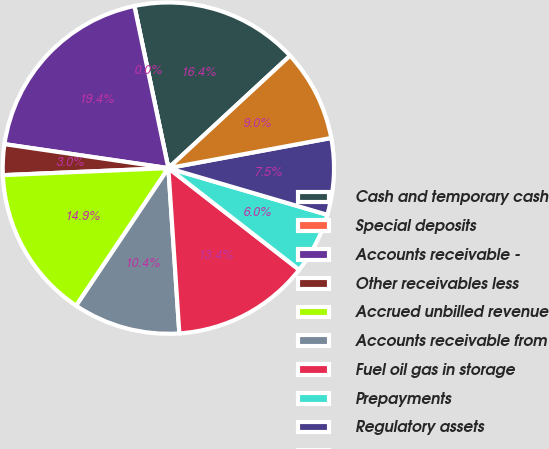Convert chart to OTSL. <chart><loc_0><loc_0><loc_500><loc_500><pie_chart><fcel>Cash and temporary cash<fcel>Special deposits<fcel>Accounts receivable -<fcel>Other receivables less<fcel>Accrued unbilled revenue<fcel>Accounts receivable from<fcel>Fuel oil gas in storage<fcel>Prepayments<fcel>Regulatory assets<fcel>Other current assets<nl><fcel>16.42%<fcel>0.0%<fcel>19.4%<fcel>2.99%<fcel>14.93%<fcel>10.45%<fcel>13.43%<fcel>5.97%<fcel>7.46%<fcel>8.96%<nl></chart> 